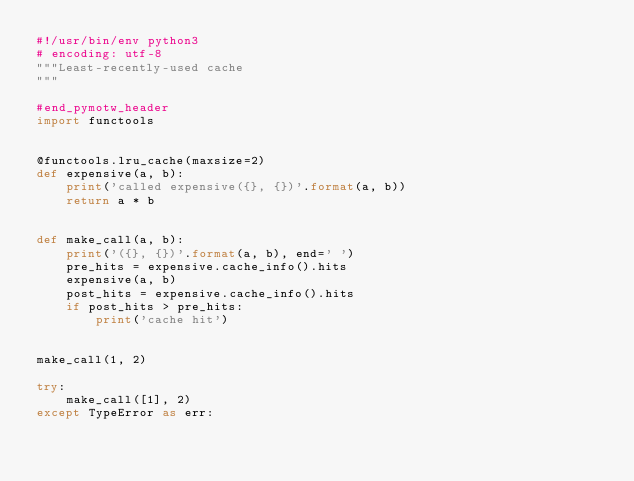Convert code to text. <code><loc_0><loc_0><loc_500><loc_500><_Python_>#!/usr/bin/env python3
# encoding: utf-8
"""Least-recently-used cache
"""

#end_pymotw_header
import functools


@functools.lru_cache(maxsize=2)
def expensive(a, b):
    print('called expensive({}, {})'.format(a, b))
    return a * b


def make_call(a, b):
    print('({}, {})'.format(a, b), end=' ')
    pre_hits = expensive.cache_info().hits
    expensive(a, b)
    post_hits = expensive.cache_info().hits
    if post_hits > pre_hits:
        print('cache hit')


make_call(1, 2)

try:
    make_call([1], 2)
except TypeError as err:</code> 